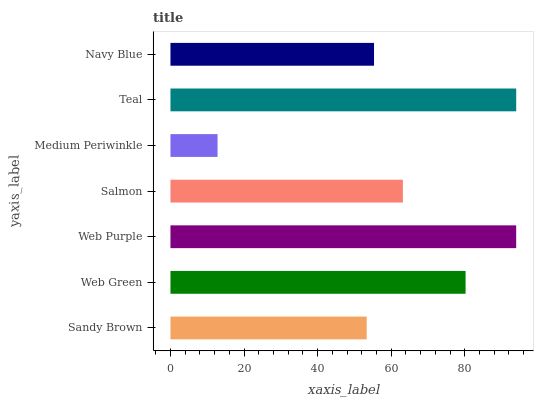Is Medium Periwinkle the minimum?
Answer yes or no. Yes. Is Teal the maximum?
Answer yes or no. Yes. Is Web Green the minimum?
Answer yes or no. No. Is Web Green the maximum?
Answer yes or no. No. Is Web Green greater than Sandy Brown?
Answer yes or no. Yes. Is Sandy Brown less than Web Green?
Answer yes or no. Yes. Is Sandy Brown greater than Web Green?
Answer yes or no. No. Is Web Green less than Sandy Brown?
Answer yes or no. No. Is Salmon the high median?
Answer yes or no. Yes. Is Salmon the low median?
Answer yes or no. Yes. Is Web Green the high median?
Answer yes or no. No. Is Teal the low median?
Answer yes or no. No. 